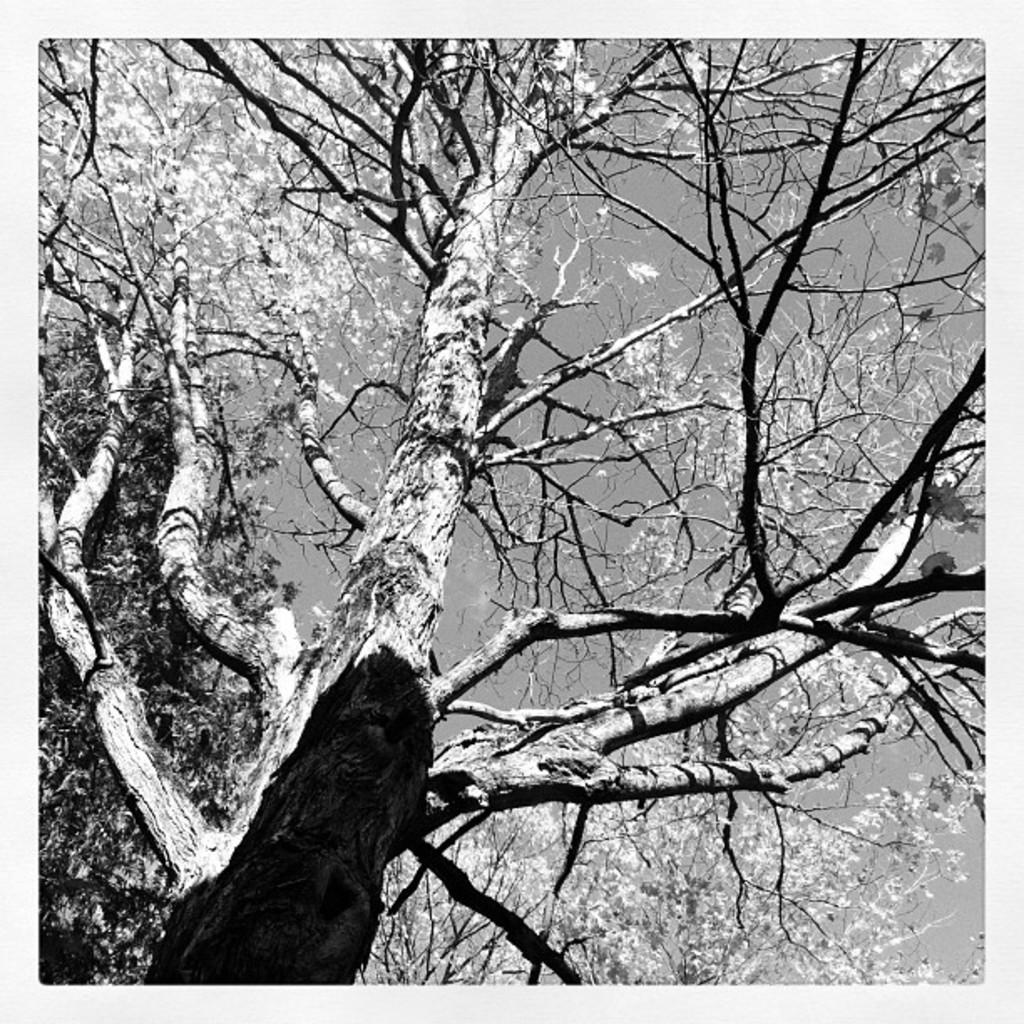What is the color scheme of the photograph? The photograph is black and white. What is the main subject of the image? The photograph depicts a dry tree. What can be seen in the background of the image? The sky is visible at the top of the image. What type of scent can be detected from the trucks in the image? There are no trucks present in the image, so it is not possible to detect any scent from them. 